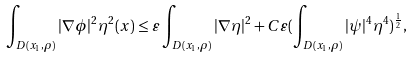Convert formula to latex. <formula><loc_0><loc_0><loc_500><loc_500>\int _ { D ( x _ { 1 } , \rho ) } | \nabla \phi | ^ { 2 } \eta ^ { 2 } ( x ) \leq \varepsilon \int _ { D ( x _ { 1 } , \rho ) } | \nabla \eta | ^ { 2 } + C \varepsilon ( \int _ { D ( x _ { 1 } , \rho ) } | \psi | ^ { 4 } \eta ^ { 4 } ) ^ { \frac { 1 } { 2 } } ,</formula> 